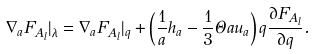<formula> <loc_0><loc_0><loc_500><loc_500>\nabla _ { a } F _ { A _ { l } } | _ { \lambda } = \nabla _ { a } F _ { A _ { l } } | _ { q } + \left ( \frac { 1 } { a } h _ { a } - \frac { 1 } { 3 } \Theta a u _ { a } \right ) q \frac { \partial F _ { A _ { l } } } { \partial q } .</formula> 